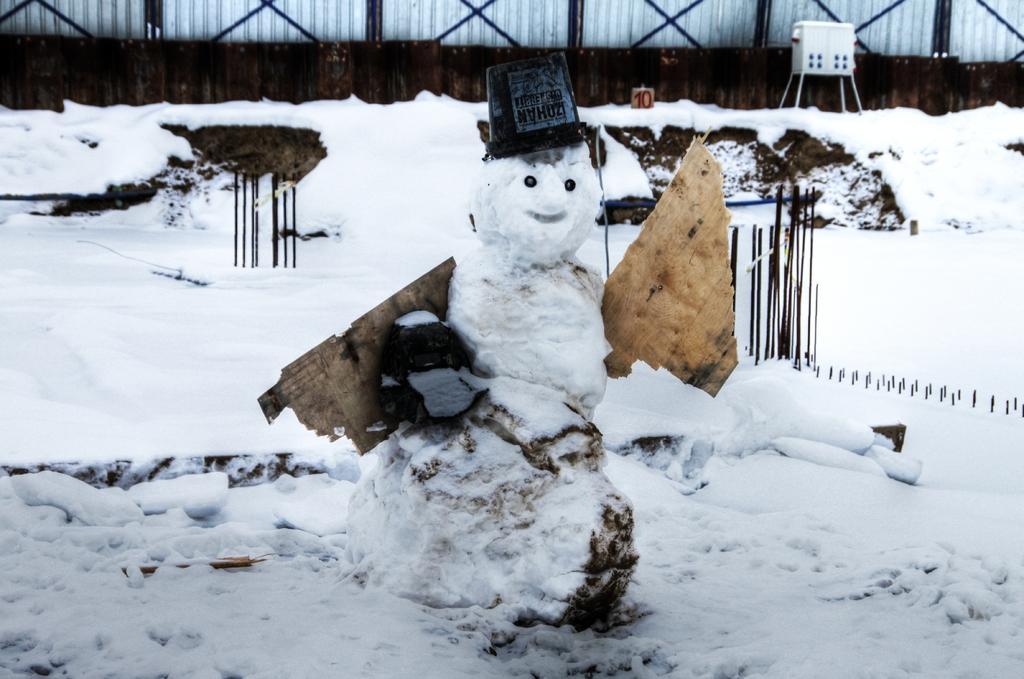How would you summarize this image in a sentence or two? In the picture I can see full of snow and there are some rods. 